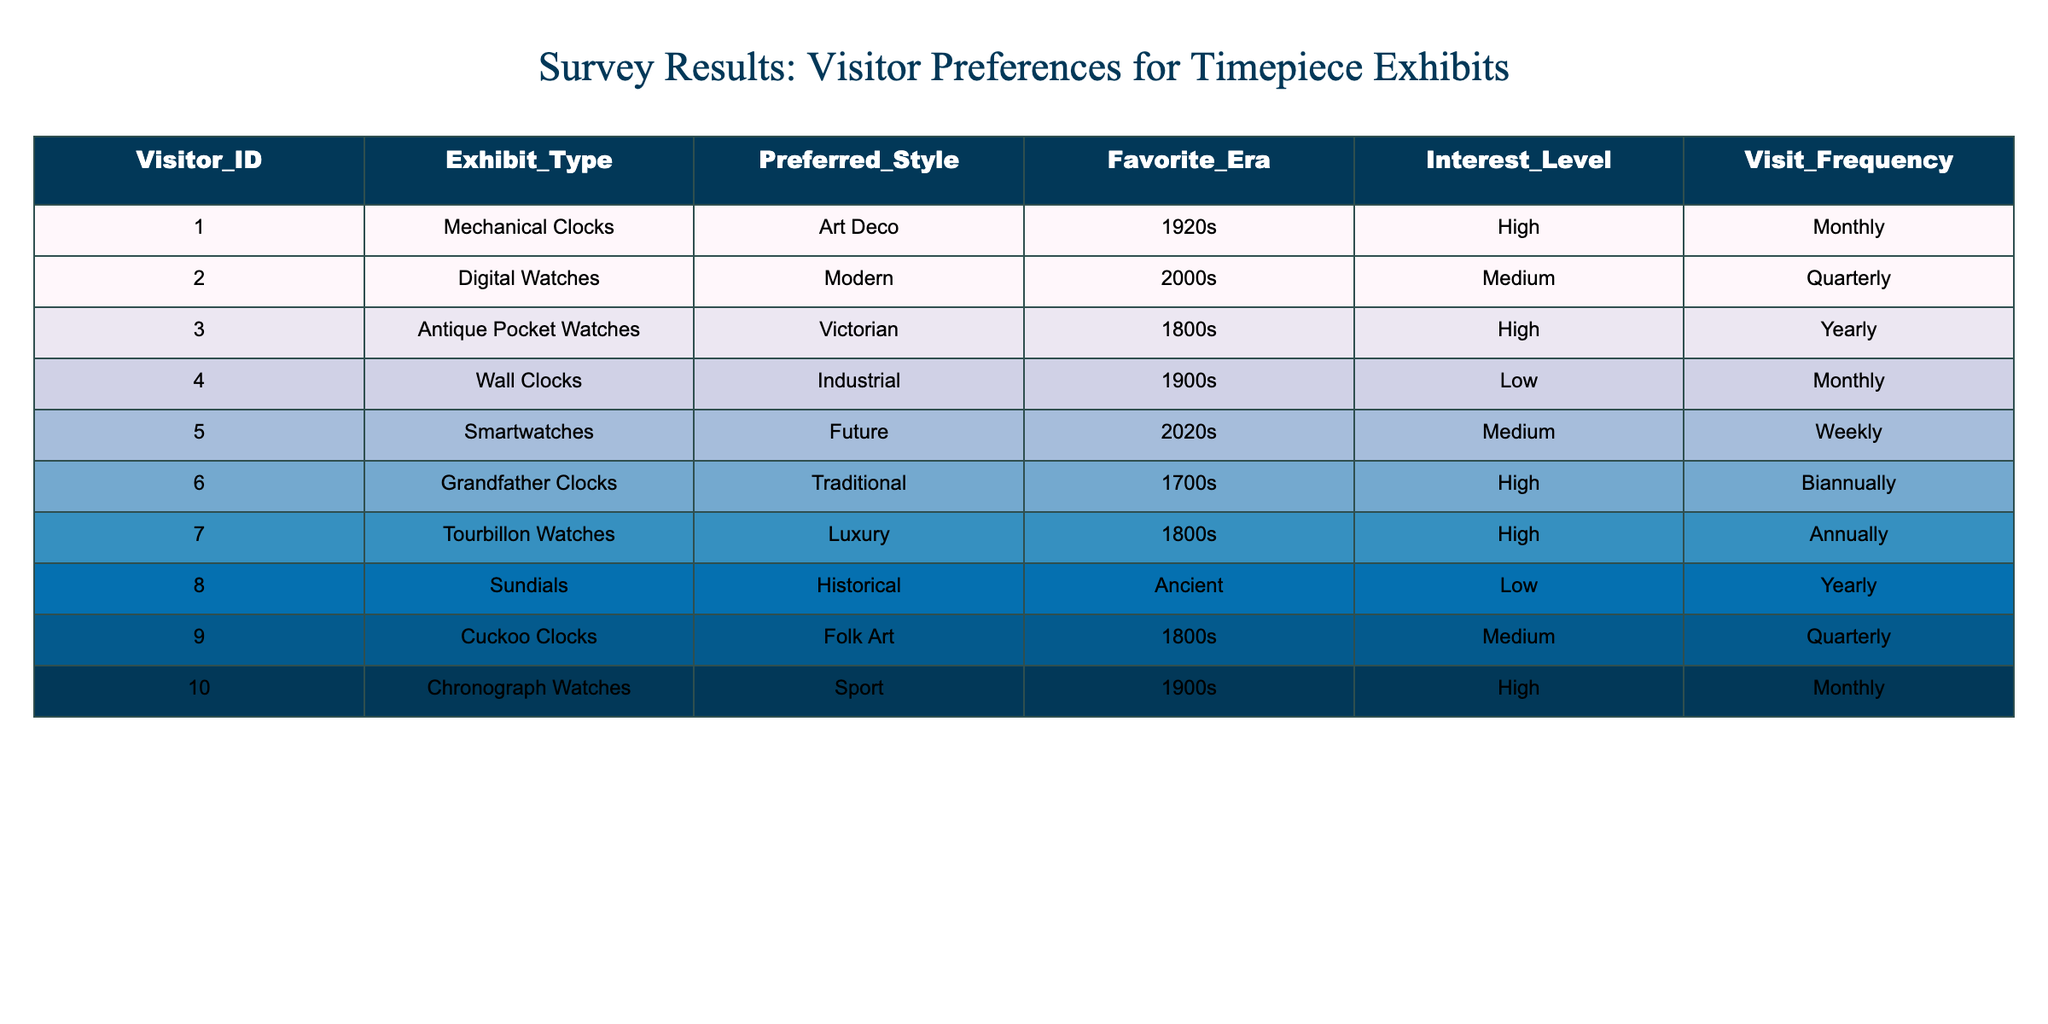What is the most preferred exhibit type among visitors? By examining the "Interest_Level" column, we see that several exhibit types have a "High" interest level. Mechanical Clocks, Antique Pocket Watches, Grandfather Clocks, Tourbillon Watches, and Chronograph Watches all fall under this category. However, the question asks for the most preferred, which in this case can be interpreted as the exhibit type with the highest frequency of high preference. Since these five types have equal preference, any can be considered equally preferred.
Answer: Mechanical Clocks, Antique Pocket Watches, Grandfather Clocks, Tourbillon Watches, Chronograph Watches How many visitors preferred digital watches? To find this out, we will look at the "Exhibit_Type" column to count how many entries are listed as "Digital Watches." Upon checking the entries, there is only 1 visitor who has indicated a preference for digital watches.
Answer: 1 What is the average visit frequency for visitors who prefer traditional styles? From the "Preferred_Style" column, the traditional styles are "Grandfather Clocks." We check the "Visit_Frequency" column for visitors who have indicated this preference. There is only one visitor who prefers Grandfather Clocks, and their visit frequency is Biannually. Since there’s only one visitor, the average is simply their visit frequency.
Answer: Biannually Are there any visitors who have a low interest level and visit frequency monthly? Looking through the "Interest_Level" and "Visit_Frequency" columns, we check for any records that show a "Low" interest level paired with a "Monthly" visit frequency. The only entry for "Low" interest is the "Wall Clocks," which does indeed have a Monthly visit frequency. Therefore, it is true that there is such a visitor.
Answer: Yes Which timepiece era has the highest number of visitors with a high interest level? To determine this, we look at the "Favorite_Era" column for entries marked with a "High" interest level. The 1800s has three visitors (Antique Pocket Watches, Tourbillon Watches, and Cuckoo Clocks), the 1900s has two visitors (Wall Clocks and Chronograph Watches), and the 1700s and 1920s each have one (Grandfather Clocks and Mechanical Clocks respectively). Thus, the 1800s has the highest number of visitors with a high interest level.
Answer: 1800s What percentage of the visitors have shown a medium interest level? We first count the total number of entries, which is 10 visitors. Then, we check how many visitors showed a "Medium" interest level, which includes Digital Watches, Smartwatches, and Cuckoo Clocks, summing to 3. To find the percentage, we use the formula (3/10) * 100 = 30%.
Answer: 30% 